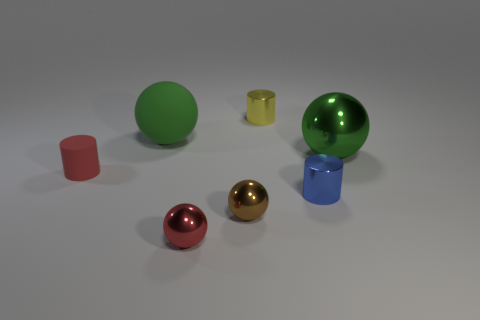Add 1 large green metallic objects. How many objects exist? 8 Subtract all spheres. How many objects are left? 3 Subtract all tiny red matte cylinders. Subtract all big gray rubber balls. How many objects are left? 6 Add 7 small blue shiny objects. How many small blue shiny objects are left? 8 Add 6 large green rubber cylinders. How many large green rubber cylinders exist? 6 Subtract 0 cyan spheres. How many objects are left? 7 